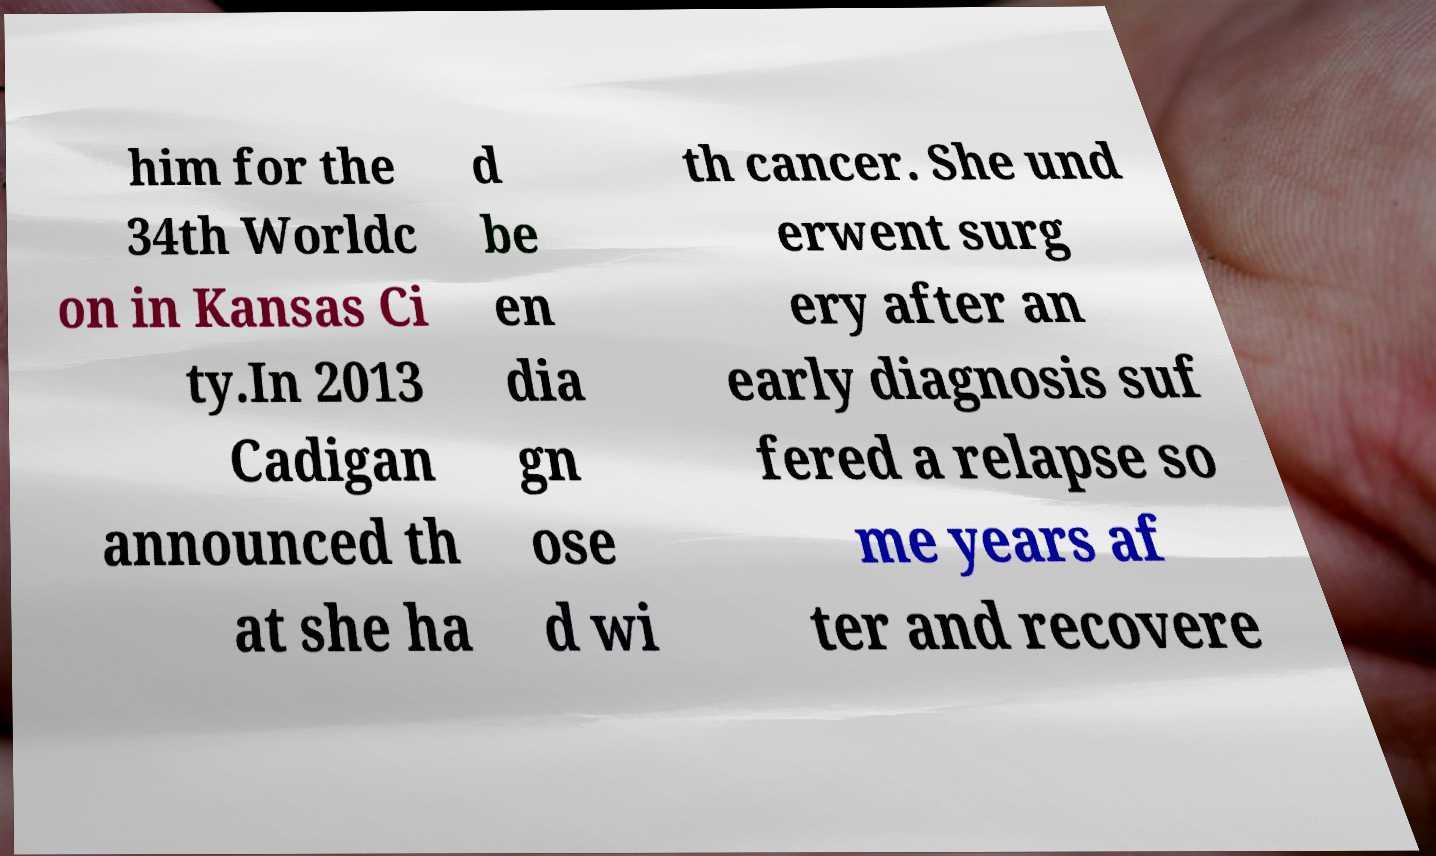For documentation purposes, I need the text within this image transcribed. Could you provide that? him for the 34th Worldc on in Kansas Ci ty.In 2013 Cadigan announced th at she ha d be en dia gn ose d wi th cancer. She und erwent surg ery after an early diagnosis suf fered a relapse so me years af ter and recovere 